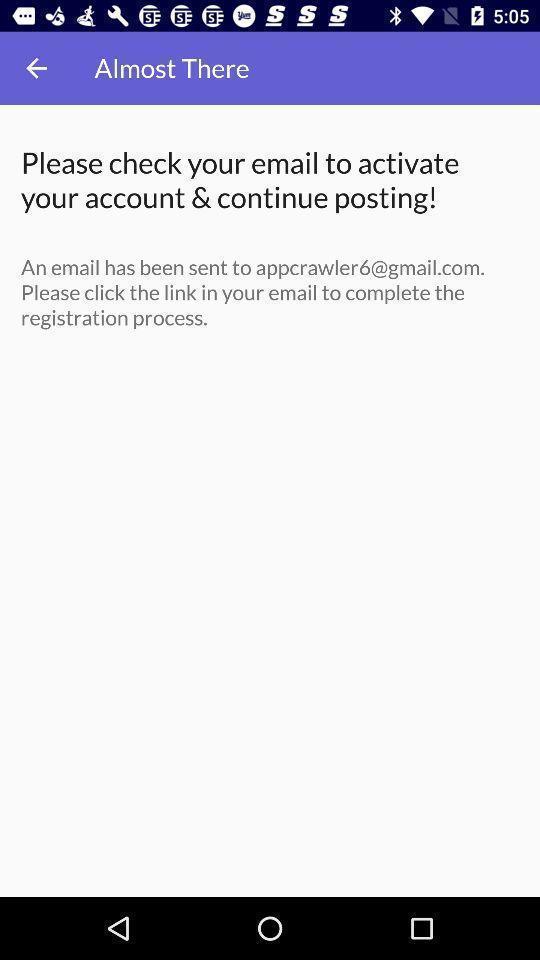Provide a detailed account of this screenshot. Page displays to click link in app for registration. 